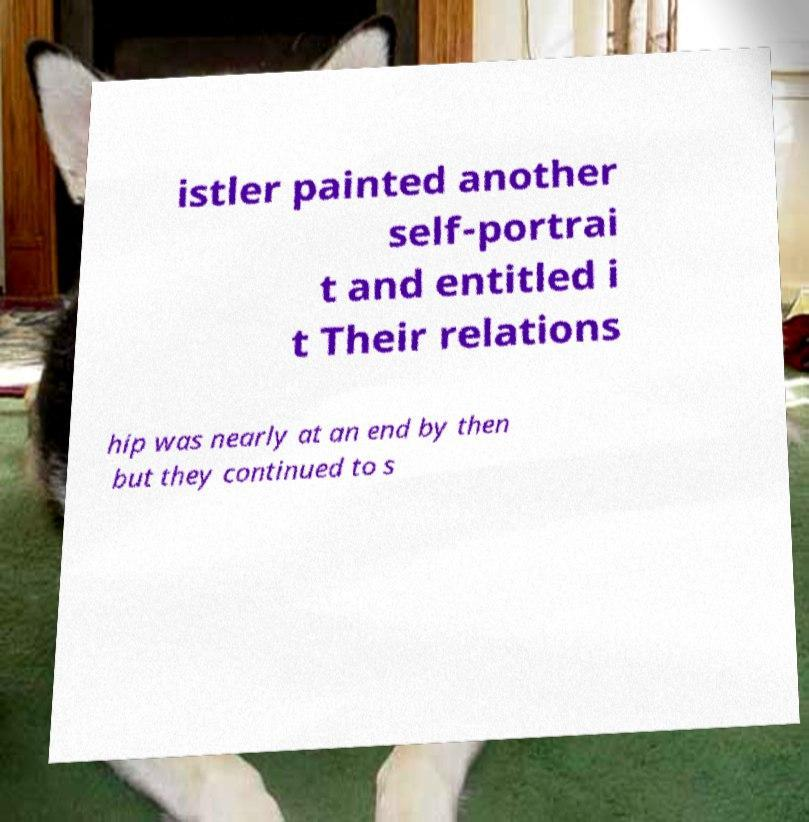Could you assist in decoding the text presented in this image and type it out clearly? istler painted another self-portrai t and entitled i t Their relations hip was nearly at an end by then but they continued to s 